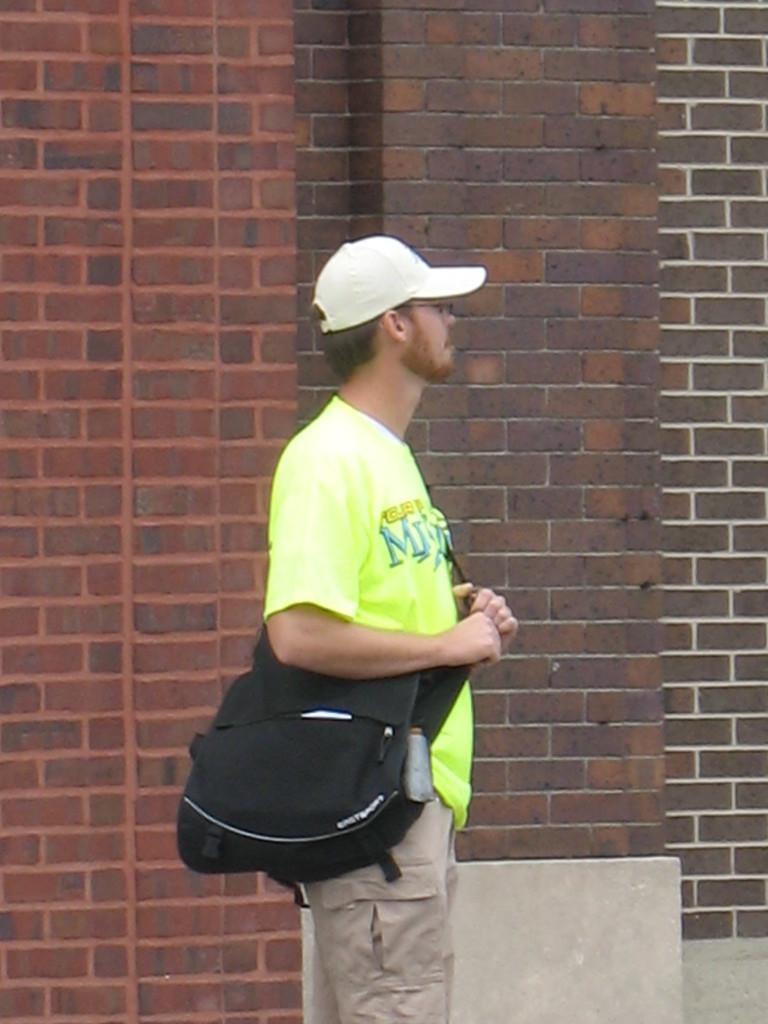Could you give a brief overview of what you see in this image? In the foreground of this image, there is a man standing and wearing a bag and a cap on his head. In the background, there is a brick wall. 